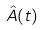Convert formula to latex. <formula><loc_0><loc_0><loc_500><loc_500>\hat { A } ( t )</formula> 